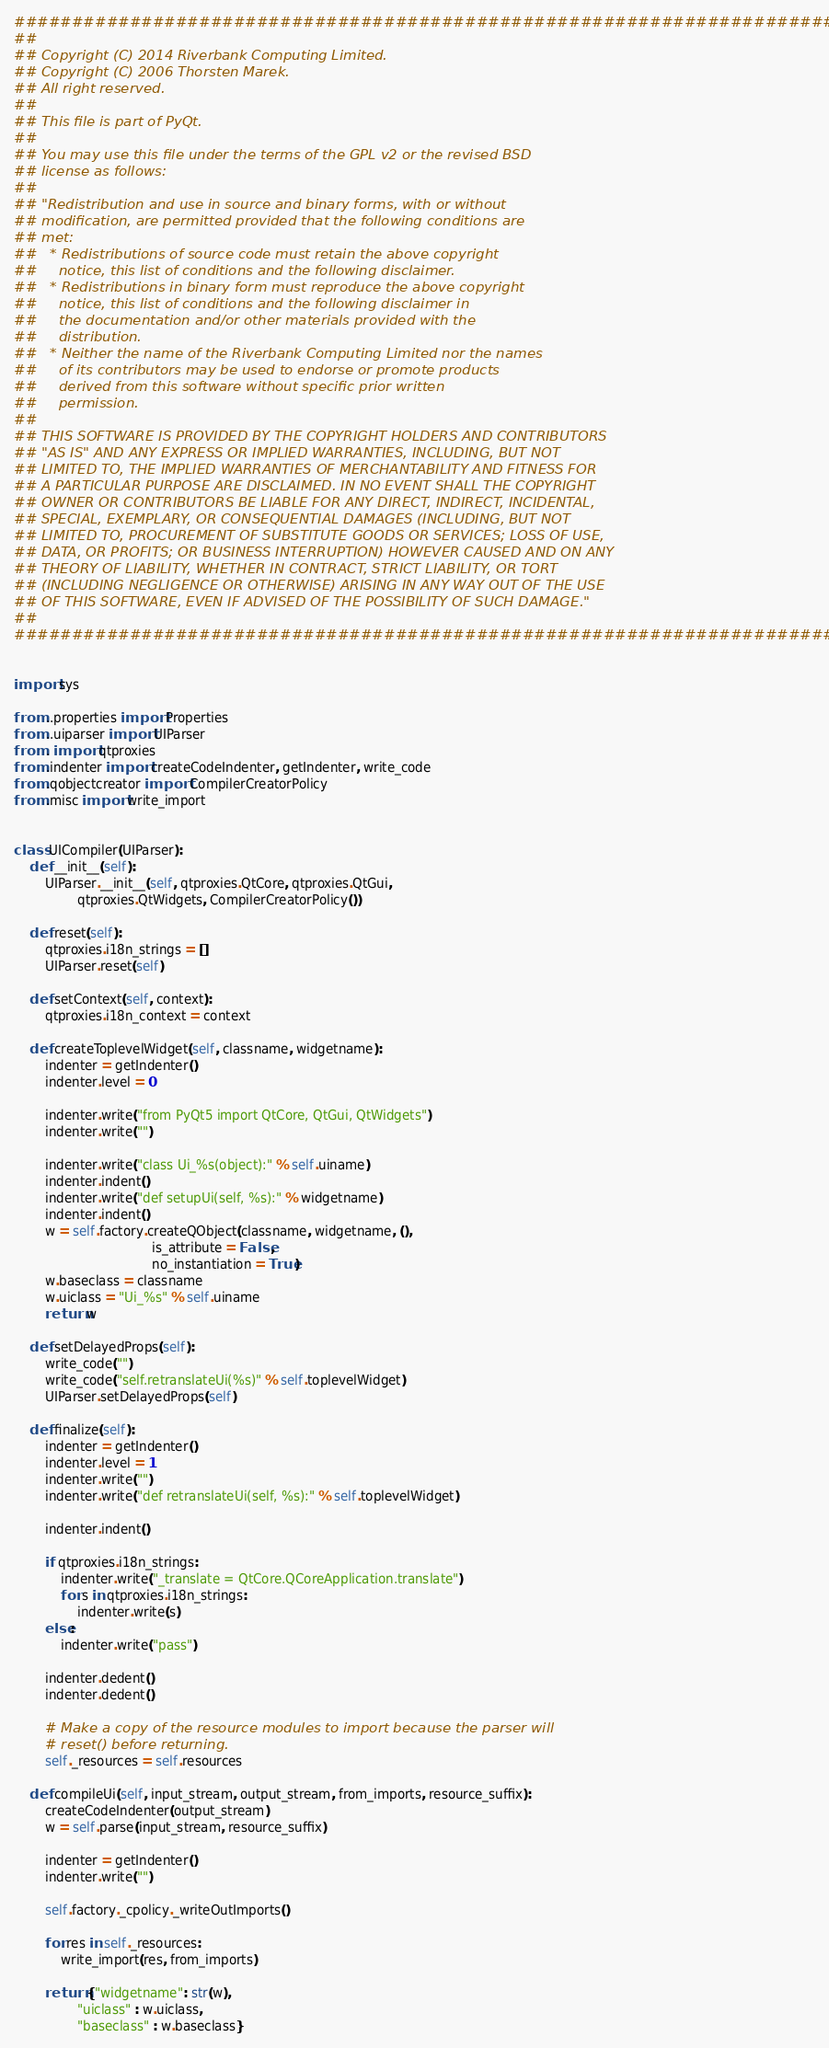Convert code to text. <code><loc_0><loc_0><loc_500><loc_500><_Python_>#############################################################################
##
## Copyright (C) 2014 Riverbank Computing Limited.
## Copyright (C) 2006 Thorsten Marek.
## All right reserved.
##
## This file is part of PyQt.
##
## You may use this file under the terms of the GPL v2 or the revised BSD
## license as follows:
##
## "Redistribution and use in source and binary forms, with or without
## modification, are permitted provided that the following conditions are
## met:
##   * Redistributions of source code must retain the above copyright
##     notice, this list of conditions and the following disclaimer.
##   * Redistributions in binary form must reproduce the above copyright
##     notice, this list of conditions and the following disclaimer in
##     the documentation and/or other materials provided with the
##     distribution.
##   * Neither the name of the Riverbank Computing Limited nor the names
##     of its contributors may be used to endorse or promote products
##     derived from this software without specific prior written
##     permission.
##
## THIS SOFTWARE IS PROVIDED BY THE COPYRIGHT HOLDERS AND CONTRIBUTORS
## "AS IS" AND ANY EXPRESS OR IMPLIED WARRANTIES, INCLUDING, BUT NOT
## LIMITED TO, THE IMPLIED WARRANTIES OF MERCHANTABILITY AND FITNESS FOR
## A PARTICULAR PURPOSE ARE DISCLAIMED. IN NO EVENT SHALL THE COPYRIGHT
## OWNER OR CONTRIBUTORS BE LIABLE FOR ANY DIRECT, INDIRECT, INCIDENTAL,
## SPECIAL, EXEMPLARY, OR CONSEQUENTIAL DAMAGES (INCLUDING, BUT NOT
## LIMITED TO, PROCUREMENT OF SUBSTITUTE GOODS OR SERVICES; LOSS OF USE,
## DATA, OR PROFITS; OR BUSINESS INTERRUPTION) HOWEVER CAUSED AND ON ANY
## THEORY OF LIABILITY, WHETHER IN CONTRACT, STRICT LIABILITY, OR TORT
## (INCLUDING NEGLIGENCE OR OTHERWISE) ARISING IN ANY WAY OUT OF THE USE
## OF THIS SOFTWARE, EVEN IF ADVISED OF THE POSSIBILITY OF SUCH DAMAGE."
##
#############################################################################


import sys

from ..properties import Properties
from ..uiparser import UIParser
from . import qtproxies
from .indenter import createCodeIndenter, getIndenter, write_code
from .qobjectcreator import CompilerCreatorPolicy
from .misc import write_import


class UICompiler(UIParser):
    def __init__(self):
        UIParser.__init__(self, qtproxies.QtCore, qtproxies.QtGui,
                qtproxies.QtWidgets, CompilerCreatorPolicy())

    def reset(self):
        qtproxies.i18n_strings = []
        UIParser.reset(self)

    def setContext(self, context):
        qtproxies.i18n_context = context

    def createToplevelWidget(self, classname, widgetname):
        indenter = getIndenter()
        indenter.level = 0

        indenter.write("from PyQt5 import QtCore, QtGui, QtWidgets")
        indenter.write("")

        indenter.write("class Ui_%s(object):" % self.uiname)
        indenter.indent()
        indenter.write("def setupUi(self, %s):" % widgetname)
        indenter.indent()
        w = self.factory.createQObject(classname, widgetname, (),
                                   is_attribute = False,
                                   no_instantiation = True)
        w.baseclass = classname
        w.uiclass = "Ui_%s" % self.uiname
        return w

    def setDelayedProps(self):
        write_code("")
        write_code("self.retranslateUi(%s)" % self.toplevelWidget)
        UIParser.setDelayedProps(self)

    def finalize(self):
        indenter = getIndenter()
        indenter.level = 1
        indenter.write("")
        indenter.write("def retranslateUi(self, %s):" % self.toplevelWidget)

        indenter.indent()

        if qtproxies.i18n_strings:
            indenter.write("_translate = QtCore.QCoreApplication.translate")
            for s in qtproxies.i18n_strings:
                indenter.write(s)
        else:
            indenter.write("pass")

        indenter.dedent()
        indenter.dedent()

        # Make a copy of the resource modules to import because the parser will
        # reset() before returning.
        self._resources = self.resources

    def compileUi(self, input_stream, output_stream, from_imports, resource_suffix):
        createCodeIndenter(output_stream)
        w = self.parse(input_stream, resource_suffix)

        indenter = getIndenter()
        indenter.write("")

        self.factory._cpolicy._writeOutImports()

        for res in self._resources:
            write_import(res, from_imports)

        return {"widgetname": str(w),
                "uiclass" : w.uiclass,
                "baseclass" : w.baseclass}
</code> 